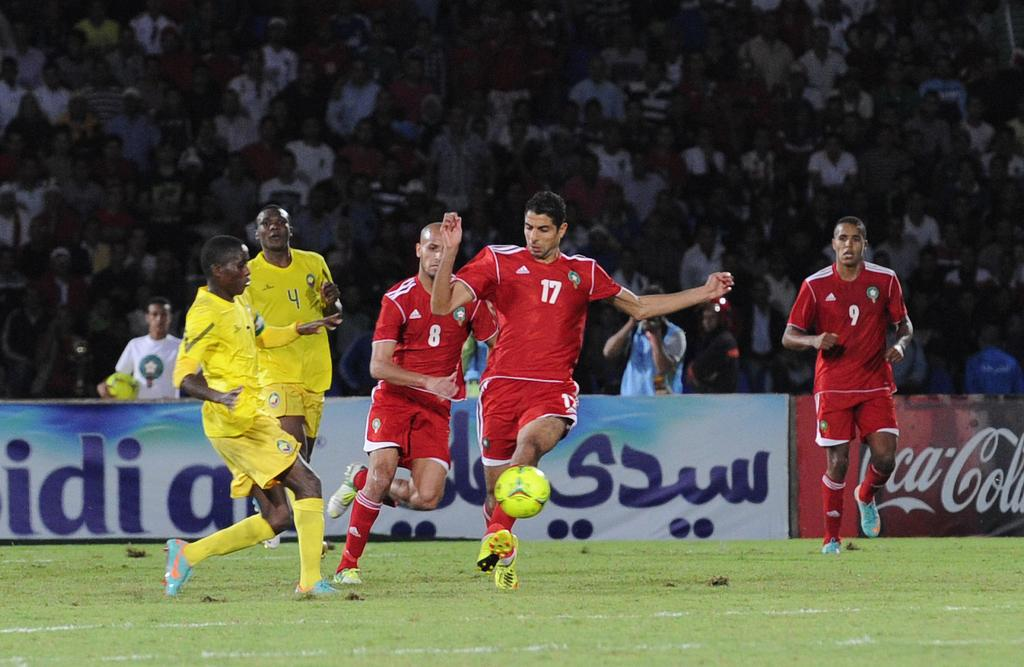<image>
Create a compact narrative representing the image presented. A soccer game is underway at a stadium with Coca-Cola ads on the walls. 